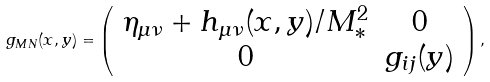<formula> <loc_0><loc_0><loc_500><loc_500>g _ { M N } ( x , y ) = \left ( \begin{array} { c c } \eta _ { \mu \nu } + h _ { \mu \nu } ( x , y ) / M _ { * } ^ { 2 } & 0 \\ 0 & g _ { i j } ( y ) \end{array} \right ) ,</formula> 